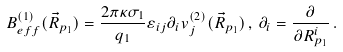Convert formula to latex. <formula><loc_0><loc_0><loc_500><loc_500>B _ { e f f } ^ { ( 1 ) } ( \vec { R } _ { p _ { 1 } } ) = \frac { 2 \pi \kappa \sigma _ { 1 } } { q _ { 1 } } \varepsilon _ { i j } \partial _ { i } v _ { j } ^ { ( 2 ) } ( \vec { R } _ { p _ { 1 } } ) \, , \, \partial _ { i } = \frac { \partial } { \partial R _ { p _ { 1 } } ^ { i } } \, .</formula> 